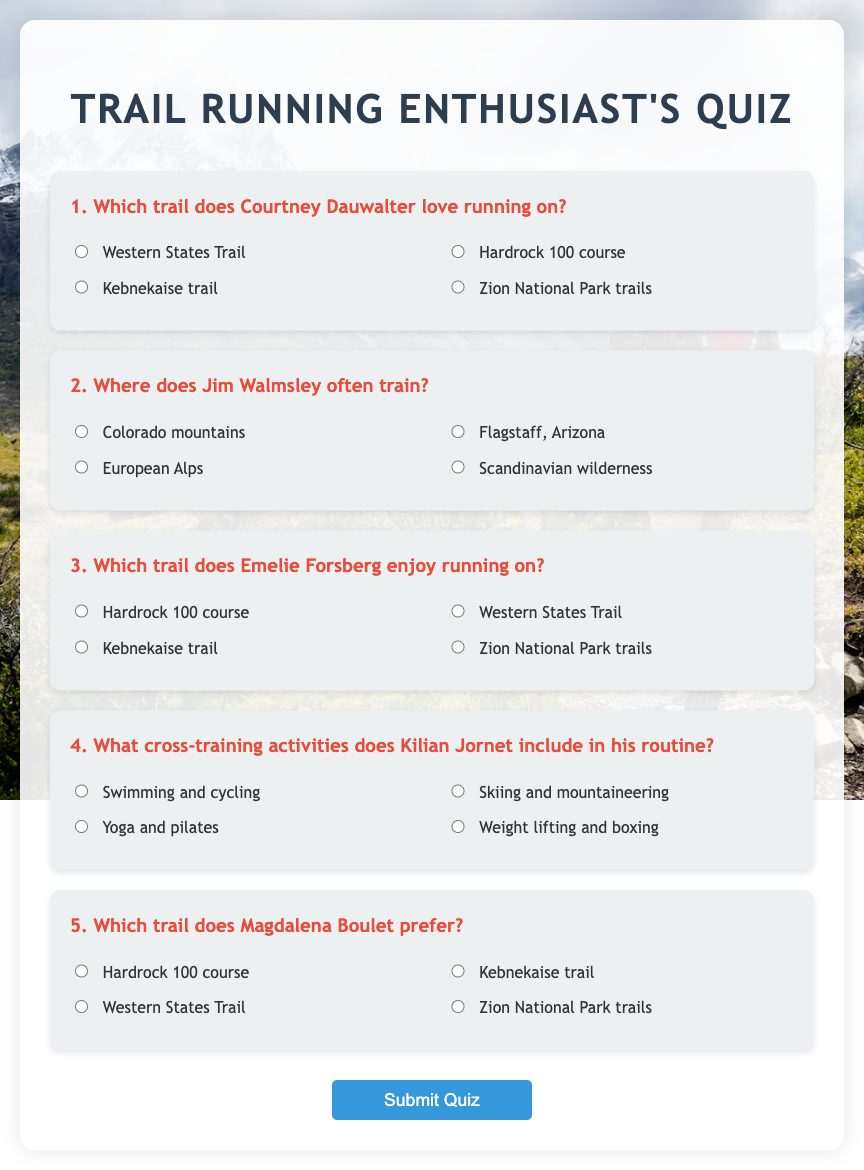What trail does Courtney Dauwalter love running on? Courtney Dauwalter loves running on the Western States Trail, as mentioned in the quiz.
Answer: Western States Trail Where does Jim Walmsley often train? Jim Walmsley often trains in Flagstaff, Arizona, according to the options provided.
Answer: Flagstaff, Arizona Which trail does Emelie Forsberg enjoy running on? Emelie Forsberg enjoys running on the Kebnekaise trail, based on the information from the document.
Answer: Kebnekaise trail What cross-training activities does Kilian Jornet include in his routine? Kilian Jornet includes swimming and cycling as his cross-training activities, as per the quiz content.
Answer: Swimming and cycling Which trail does Magdalena Boulet prefer? Magdalena Boulet prefers the Hardrock 100 course, as identified in the list of questions.
Answer: Hardrock 100 course 